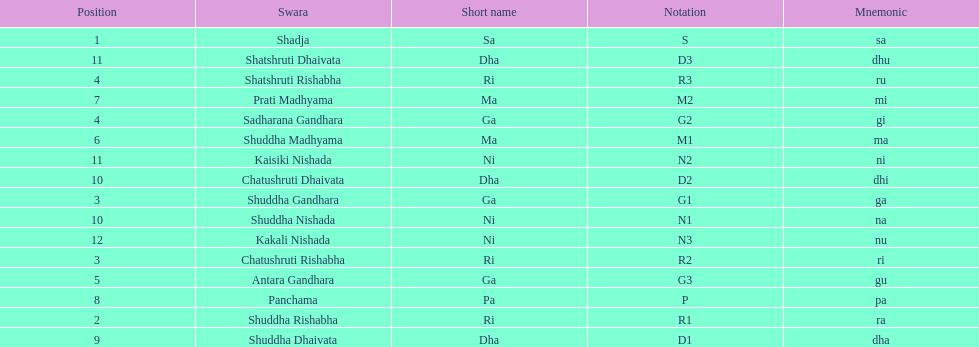Find the 9th position swara. what is its short name? Dha. Parse the table in full. {'header': ['Position', 'Swara', 'Short name', 'Notation', 'Mnemonic'], 'rows': [['1', 'Shadja', 'Sa', 'S', 'sa'], ['11', 'Shatshruti Dhaivata', 'Dha', 'D3', 'dhu'], ['4', 'Shatshruti Rishabha', 'Ri', 'R3', 'ru'], ['7', 'Prati Madhyama', 'Ma', 'M2', 'mi'], ['4', 'Sadharana Gandhara', 'Ga', 'G2', 'gi'], ['6', 'Shuddha Madhyama', 'Ma', 'M1', 'ma'], ['11', 'Kaisiki Nishada', 'Ni', 'N2', 'ni'], ['10', 'Chatushruti Dhaivata', 'Dha', 'D2', 'dhi'], ['3', 'Shuddha Gandhara', 'Ga', 'G1', 'ga'], ['10', 'Shuddha Nishada', 'Ni', 'N1', 'na'], ['12', 'Kakali Nishada', 'Ni', 'N3', 'nu'], ['3', 'Chatushruti Rishabha', 'Ri', 'R2', 'ri'], ['5', 'Antara Gandhara', 'Ga', 'G3', 'gu'], ['8', 'Panchama', 'Pa', 'P', 'pa'], ['2', 'Shuddha Rishabha', 'Ri', 'R1', 'ra'], ['9', 'Shuddha Dhaivata', 'Dha', 'D1', 'dha']]} 